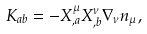<formula> <loc_0><loc_0><loc_500><loc_500>K _ { a b } = - X ^ { \mu } _ { , a } X ^ { \nu } _ { , b } { \nabla } _ { \nu } n _ { \mu } ,</formula> 